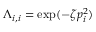Convert formula to latex. <formula><loc_0><loc_0><loc_500><loc_500>\Lambda _ { i , i } = \exp ( - \zeta p _ { i } ^ { 2 } )</formula> 